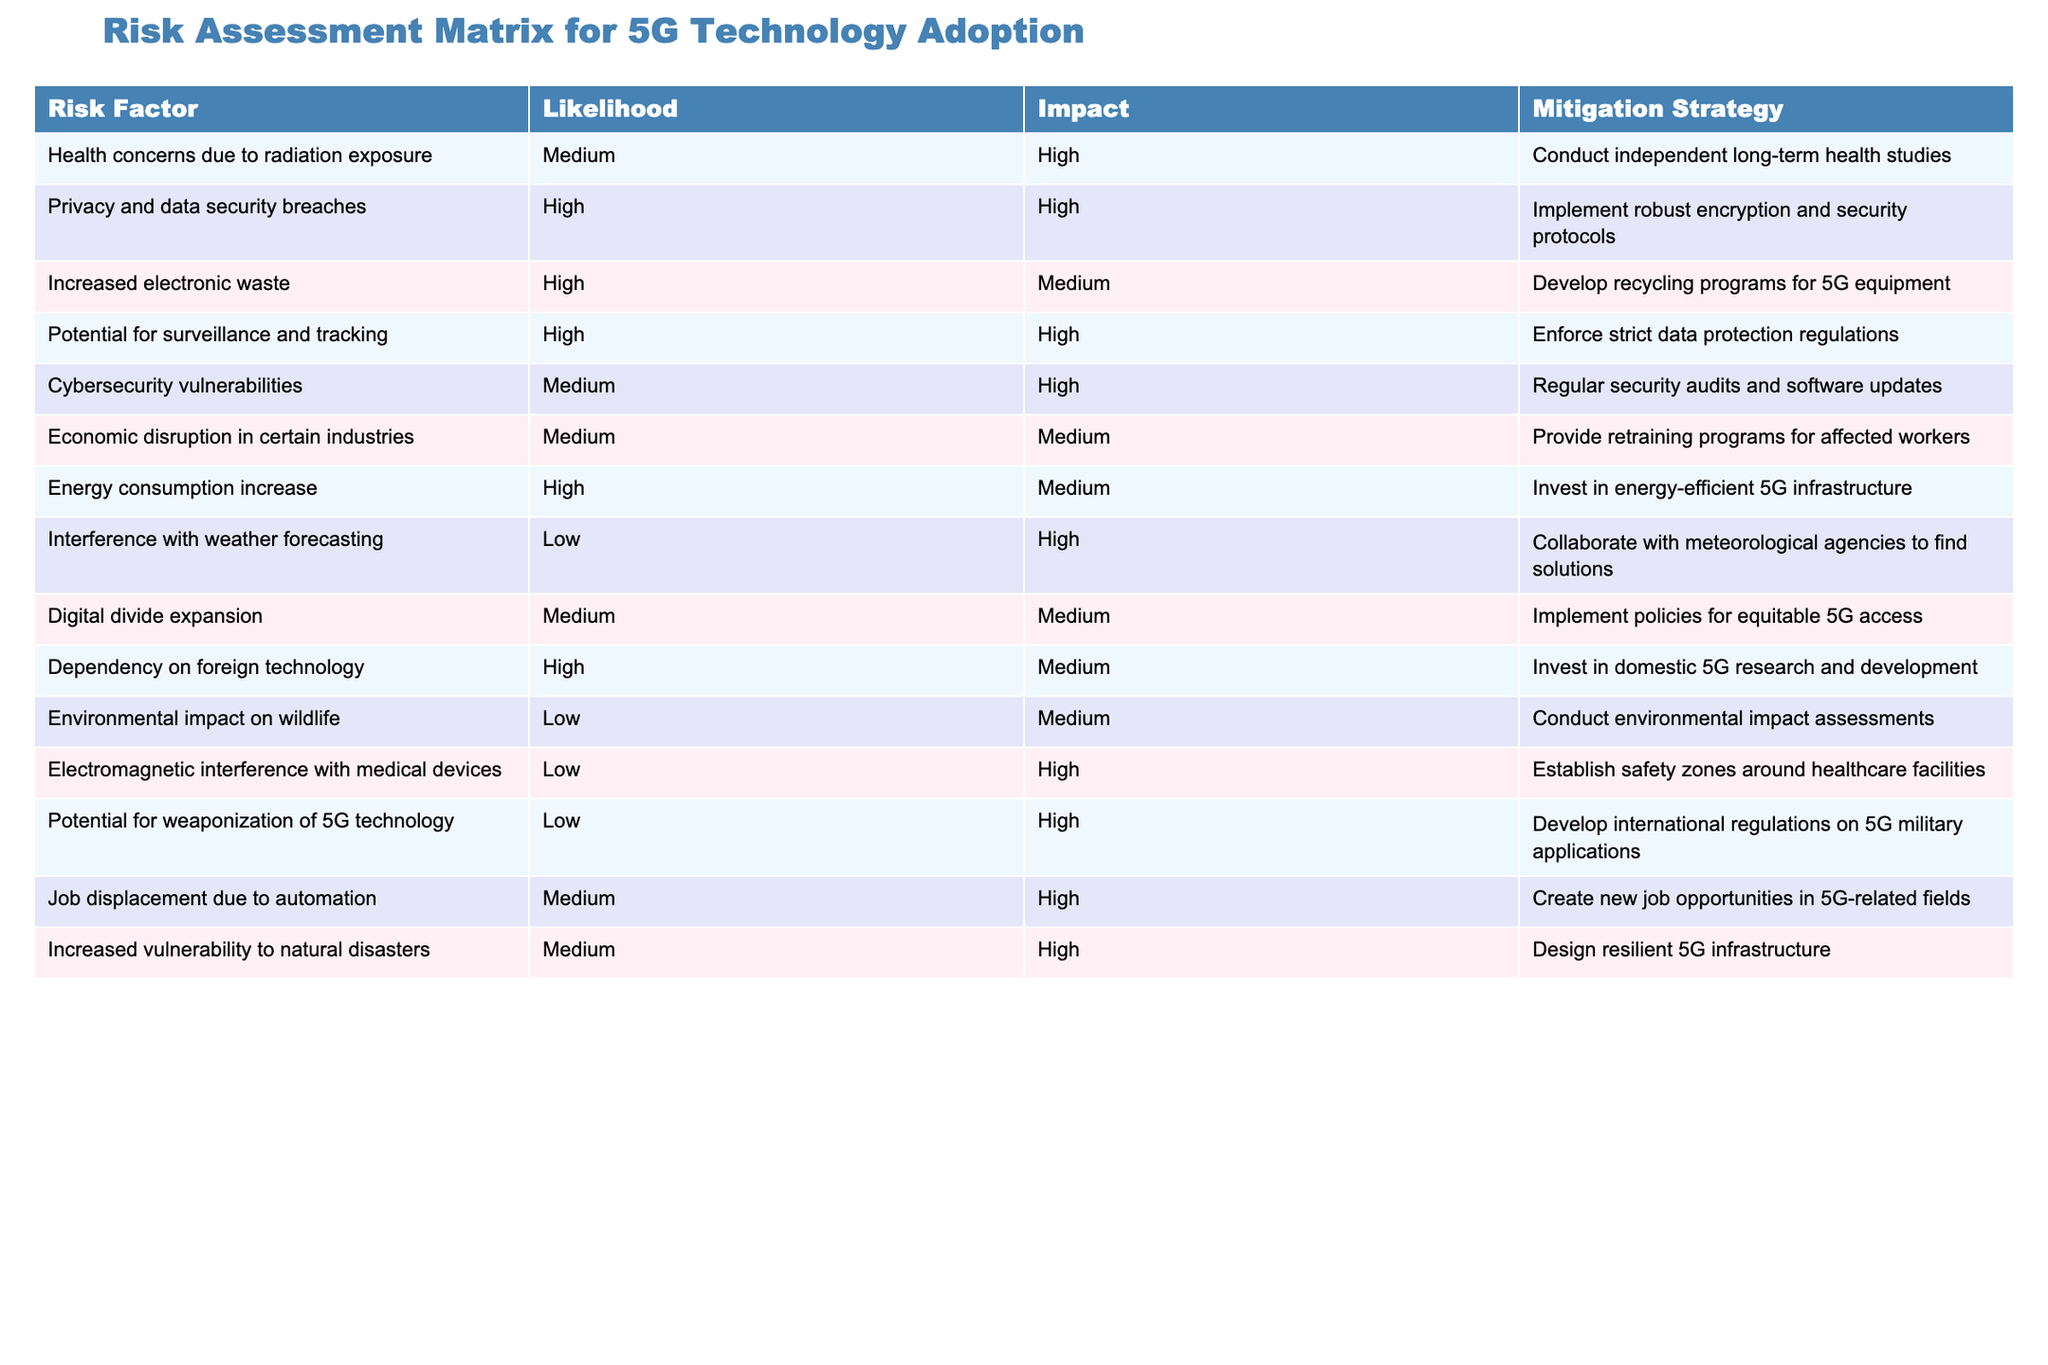What is the mitigation strategy for health concerns due to radiation exposure? According to the table, the mitigation strategy listed for health concerns due to radiation exposure is to conduct independent long-term health studies.
Answer: Conduct independent long-term health studies How many risk factors have a high likelihood and high impact? There are four risk factors in the table that have both high likelihood and high impact: privacy and data security breaches, potential for surveillance and tracking, cybersecurity vulnerabilities, and job displacement due to automation.
Answer: Four Is there a risk factor associated with low likelihood and high impact? Yes, the table includes two risk factors that have low likelihood but high impact: interference with weather forecasting and electromagnetic interference with medical devices.
Answer: Yes What is the impact level of increased electronic waste? In the table, the impact level of increased electronic waste is classified as medium.
Answer: Medium What are the mitigation strategies for risk factors with a high likelihood? The table presents several mitigation strategies for risk factors with high likelihood: implement robust encryption and security protocols for privacy and data security breaches, develop recycling programs for 5G equipment in the case of increased electronic waste, enforce strict data protection regulations for potential surveillance and tracking, invest in energy-efficient 5G infrastructure for energy consumption increase, invest in domestic 5G research and development for dependency on foreign technology.
Answer: Various strategies listed above 